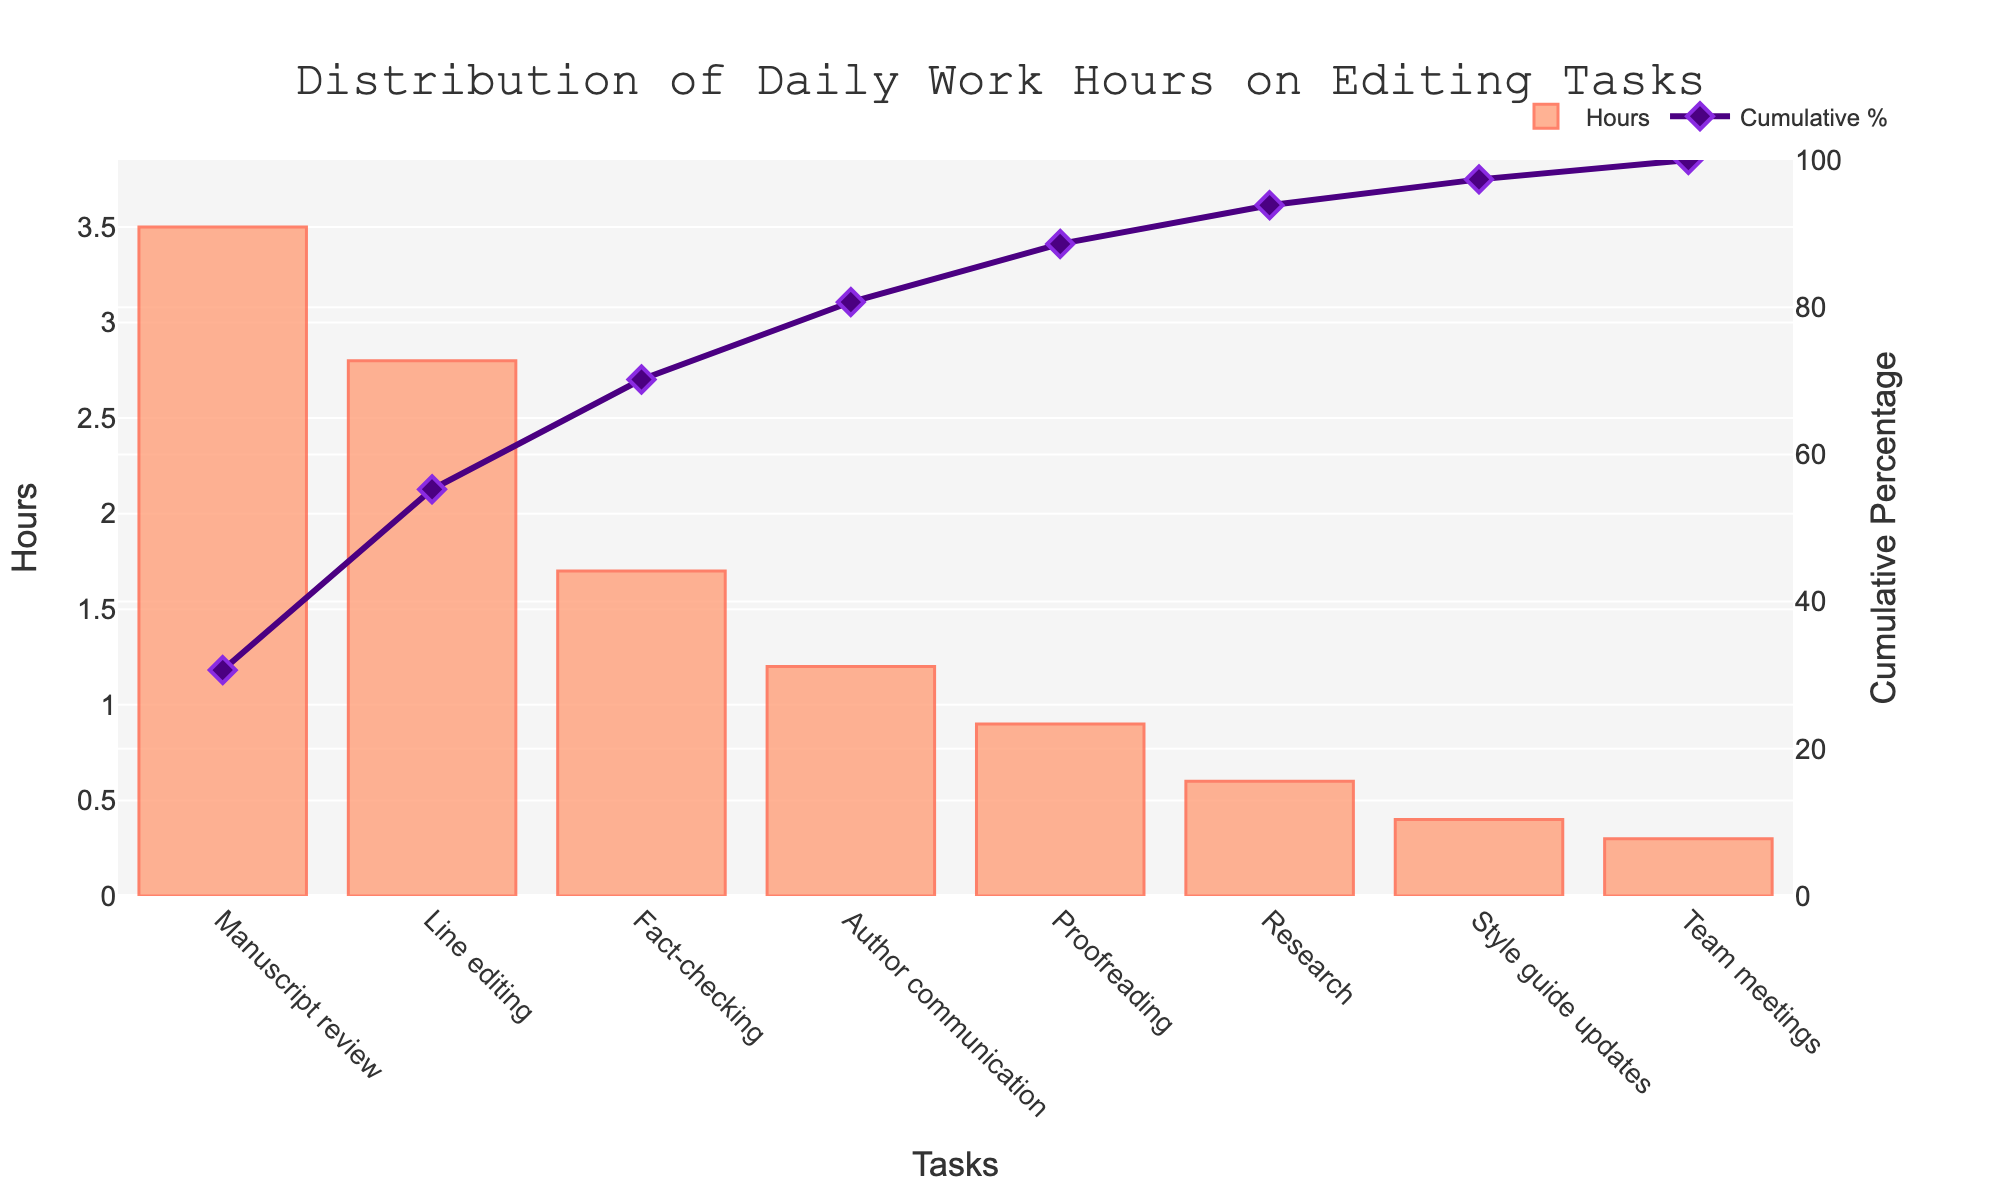What's the title of the chart? The title of the chart is displayed prominently at the top and reads "Distribution of Daily Work Hours on Editing Tasks."
Answer: Distribution of Daily Work Hours on Editing Tasks Which task has the highest number of hours spent? The bar with the highest value represents the task with the maximum hours, which is "Manuscript review" at 3.5 hours.
Answer: Manuscript review What is the total number of hours spent on tasks with at least 2 hours each? Sum the hours for tasks that have 2 or more hours: "Manuscript review" (3.5) and "Line editing" (2.8), giving a total of 3.5 + 2.8 = 6.3 hours.
Answer: 6.3 By what percentage does "Fact-checking" contribute to the cumulative percentage? Find "Fact-checking" on the x-axis and look up its corresponding value on the secondary y-axis, which shows a cumulative percentage around 74%. Since "Line editing" ends at about 58%, the contribution from "Fact-checking" is about 74% - 58% = 16%.
Answer: 16% Which tasks contribute to over 80% of the cumulative percentage? The tasks with cumulative percentages over 80% can be seen by checking which ones surpass the 80% mark on the secondary y-axis. These tasks are "Manuscript review," "Line editing," "Fact-checking," "Author communication," and "Proofreading."
Answer: Manuscript review, Line editing, Fact-checking, Author communication, Proofreading How many tasks are represented in the chart? Count the individual bars on the x-axis, which represent the tasks. There are 8 tasks shown.
Answer: 8 What is the cumulative percentage after "Research"? "Research" is plotted on the x-axis, and the corresponding cumulative percentage for "Research" can be found on the secondary y-axis, which is approximately 96%.
Answer: 96% Which task has the least number of hours spent? The smallest bar on the chart represents the task with the least hours, which is "Team meetings" at 0.3 hours.
Answer: Team meetings How much more time is spent on "Proofreading" compared to "Style guide updates"? Subtract the hours spent on "Style guide updates" (0.4) from the hours spent on "Proofreading" (0.9). So, 0.9 - 0.4 = 0.5 hours more.
Answer: 0.5 hours What is the cumulative percentage after the first three tasks are completed? The cumulative percentage after "Manuscript review," "Line editing," and "Fact-checking" can be seen on the secondary y-axis, which adds up to around 74%.
Answer: 74% 